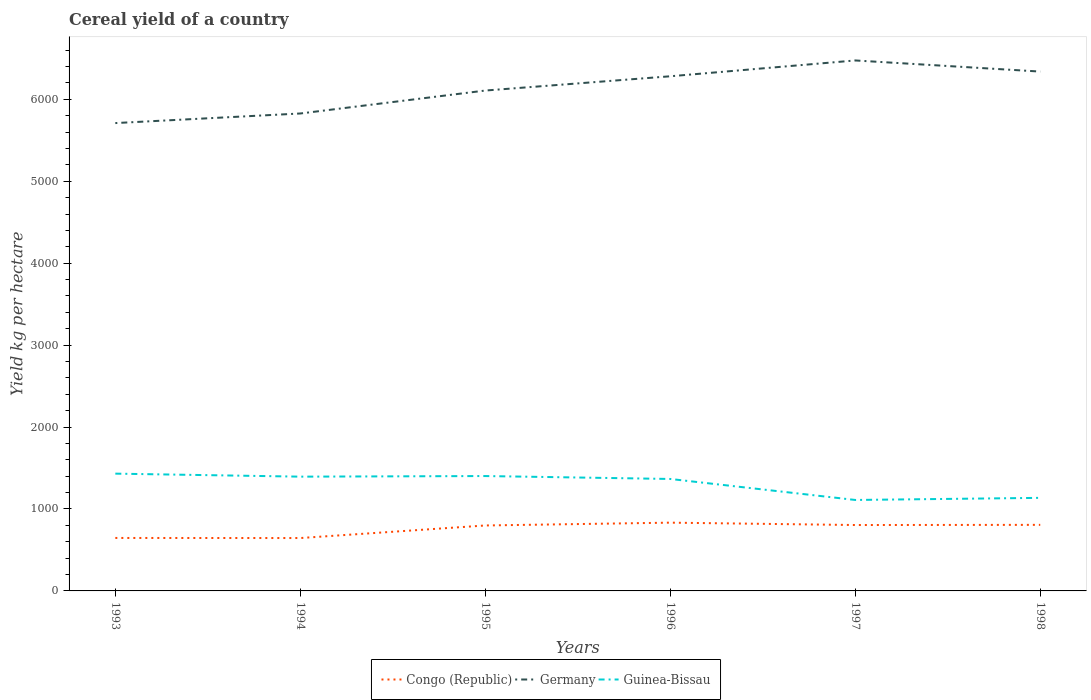Is the number of lines equal to the number of legend labels?
Ensure brevity in your answer.  Yes. Across all years, what is the maximum total cereal yield in Germany?
Offer a very short reply. 5710.53. What is the total total cereal yield in Germany in the graph?
Your answer should be very brief. -117.07. What is the difference between the highest and the second highest total cereal yield in Congo (Republic)?
Provide a short and direct response. 187.81. What is the difference between the highest and the lowest total cereal yield in Guinea-Bissau?
Provide a succinct answer. 4. How many lines are there?
Your response must be concise. 3. How many years are there in the graph?
Give a very brief answer. 6. Are the values on the major ticks of Y-axis written in scientific E-notation?
Give a very brief answer. No. Does the graph contain any zero values?
Ensure brevity in your answer.  No. Does the graph contain grids?
Provide a short and direct response. No. How many legend labels are there?
Ensure brevity in your answer.  3. How are the legend labels stacked?
Offer a very short reply. Horizontal. What is the title of the graph?
Ensure brevity in your answer.  Cereal yield of a country. What is the label or title of the X-axis?
Your answer should be compact. Years. What is the label or title of the Y-axis?
Your answer should be compact. Yield kg per hectare. What is the Yield kg per hectare in Congo (Republic) in 1993?
Your answer should be compact. 646.49. What is the Yield kg per hectare in Germany in 1993?
Your response must be concise. 5710.53. What is the Yield kg per hectare of Guinea-Bissau in 1993?
Your answer should be very brief. 1431.55. What is the Yield kg per hectare of Congo (Republic) in 1994?
Make the answer very short. 645.48. What is the Yield kg per hectare of Germany in 1994?
Your answer should be very brief. 5827.6. What is the Yield kg per hectare of Guinea-Bissau in 1994?
Provide a succinct answer. 1394.79. What is the Yield kg per hectare of Congo (Republic) in 1995?
Keep it short and to the point. 798.93. What is the Yield kg per hectare of Germany in 1995?
Your response must be concise. 6107.68. What is the Yield kg per hectare of Guinea-Bissau in 1995?
Ensure brevity in your answer.  1402.23. What is the Yield kg per hectare of Congo (Republic) in 1996?
Keep it short and to the point. 833.29. What is the Yield kg per hectare in Germany in 1996?
Make the answer very short. 6281.85. What is the Yield kg per hectare in Guinea-Bissau in 1996?
Provide a succinct answer. 1366.54. What is the Yield kg per hectare of Congo (Republic) in 1997?
Offer a very short reply. 804.34. What is the Yield kg per hectare of Germany in 1997?
Provide a succinct answer. 6474.95. What is the Yield kg per hectare in Guinea-Bissau in 1997?
Offer a terse response. 1110.25. What is the Yield kg per hectare of Congo (Republic) in 1998?
Your answer should be very brief. 806.46. What is the Yield kg per hectare in Germany in 1998?
Give a very brief answer. 6339.19. What is the Yield kg per hectare in Guinea-Bissau in 1998?
Your answer should be compact. 1136. Across all years, what is the maximum Yield kg per hectare of Congo (Republic)?
Make the answer very short. 833.29. Across all years, what is the maximum Yield kg per hectare of Germany?
Ensure brevity in your answer.  6474.95. Across all years, what is the maximum Yield kg per hectare of Guinea-Bissau?
Offer a very short reply. 1431.55. Across all years, what is the minimum Yield kg per hectare in Congo (Republic)?
Offer a terse response. 645.48. Across all years, what is the minimum Yield kg per hectare of Germany?
Your answer should be compact. 5710.53. Across all years, what is the minimum Yield kg per hectare in Guinea-Bissau?
Your response must be concise. 1110.25. What is the total Yield kg per hectare in Congo (Republic) in the graph?
Provide a succinct answer. 4534.99. What is the total Yield kg per hectare in Germany in the graph?
Your answer should be compact. 3.67e+04. What is the total Yield kg per hectare of Guinea-Bissau in the graph?
Your answer should be compact. 7841.37. What is the difference between the Yield kg per hectare in Congo (Republic) in 1993 and that in 1994?
Give a very brief answer. 1.01. What is the difference between the Yield kg per hectare of Germany in 1993 and that in 1994?
Your answer should be compact. -117.07. What is the difference between the Yield kg per hectare in Guinea-Bissau in 1993 and that in 1994?
Offer a terse response. 36.76. What is the difference between the Yield kg per hectare of Congo (Republic) in 1993 and that in 1995?
Offer a very short reply. -152.44. What is the difference between the Yield kg per hectare of Germany in 1993 and that in 1995?
Your answer should be compact. -397.15. What is the difference between the Yield kg per hectare in Guinea-Bissau in 1993 and that in 1995?
Offer a very short reply. 29.33. What is the difference between the Yield kg per hectare of Congo (Republic) in 1993 and that in 1996?
Offer a terse response. -186.8. What is the difference between the Yield kg per hectare in Germany in 1993 and that in 1996?
Provide a short and direct response. -571.32. What is the difference between the Yield kg per hectare of Guinea-Bissau in 1993 and that in 1996?
Give a very brief answer. 65.01. What is the difference between the Yield kg per hectare of Congo (Republic) in 1993 and that in 1997?
Make the answer very short. -157.84. What is the difference between the Yield kg per hectare in Germany in 1993 and that in 1997?
Make the answer very short. -764.43. What is the difference between the Yield kg per hectare of Guinea-Bissau in 1993 and that in 1997?
Your answer should be compact. 321.3. What is the difference between the Yield kg per hectare of Congo (Republic) in 1993 and that in 1998?
Give a very brief answer. -159.96. What is the difference between the Yield kg per hectare in Germany in 1993 and that in 1998?
Offer a terse response. -628.66. What is the difference between the Yield kg per hectare in Guinea-Bissau in 1993 and that in 1998?
Give a very brief answer. 295.55. What is the difference between the Yield kg per hectare of Congo (Republic) in 1994 and that in 1995?
Keep it short and to the point. -153.46. What is the difference between the Yield kg per hectare of Germany in 1994 and that in 1995?
Provide a short and direct response. -280.08. What is the difference between the Yield kg per hectare in Guinea-Bissau in 1994 and that in 1995?
Your response must be concise. -7.43. What is the difference between the Yield kg per hectare in Congo (Republic) in 1994 and that in 1996?
Keep it short and to the point. -187.81. What is the difference between the Yield kg per hectare of Germany in 1994 and that in 1996?
Give a very brief answer. -454.25. What is the difference between the Yield kg per hectare in Guinea-Bissau in 1994 and that in 1996?
Offer a very short reply. 28.25. What is the difference between the Yield kg per hectare of Congo (Republic) in 1994 and that in 1997?
Ensure brevity in your answer.  -158.86. What is the difference between the Yield kg per hectare in Germany in 1994 and that in 1997?
Provide a succinct answer. -647.36. What is the difference between the Yield kg per hectare in Guinea-Bissau in 1994 and that in 1997?
Ensure brevity in your answer.  284.54. What is the difference between the Yield kg per hectare of Congo (Republic) in 1994 and that in 1998?
Your answer should be compact. -160.98. What is the difference between the Yield kg per hectare of Germany in 1994 and that in 1998?
Give a very brief answer. -511.59. What is the difference between the Yield kg per hectare of Guinea-Bissau in 1994 and that in 1998?
Ensure brevity in your answer.  258.79. What is the difference between the Yield kg per hectare of Congo (Republic) in 1995 and that in 1996?
Ensure brevity in your answer.  -34.35. What is the difference between the Yield kg per hectare in Germany in 1995 and that in 1996?
Your answer should be very brief. -174.17. What is the difference between the Yield kg per hectare in Guinea-Bissau in 1995 and that in 1996?
Keep it short and to the point. 35.68. What is the difference between the Yield kg per hectare of Congo (Republic) in 1995 and that in 1997?
Give a very brief answer. -5.4. What is the difference between the Yield kg per hectare of Germany in 1995 and that in 1997?
Your answer should be compact. -367.28. What is the difference between the Yield kg per hectare of Guinea-Bissau in 1995 and that in 1997?
Your answer should be compact. 291.98. What is the difference between the Yield kg per hectare of Congo (Republic) in 1995 and that in 1998?
Give a very brief answer. -7.52. What is the difference between the Yield kg per hectare of Germany in 1995 and that in 1998?
Make the answer very short. -231.51. What is the difference between the Yield kg per hectare of Guinea-Bissau in 1995 and that in 1998?
Offer a very short reply. 266.23. What is the difference between the Yield kg per hectare in Congo (Republic) in 1996 and that in 1997?
Provide a succinct answer. 28.95. What is the difference between the Yield kg per hectare in Germany in 1996 and that in 1997?
Provide a succinct answer. -193.11. What is the difference between the Yield kg per hectare of Guinea-Bissau in 1996 and that in 1997?
Provide a short and direct response. 256.29. What is the difference between the Yield kg per hectare in Congo (Republic) in 1996 and that in 1998?
Keep it short and to the point. 26.83. What is the difference between the Yield kg per hectare of Germany in 1996 and that in 1998?
Offer a terse response. -57.34. What is the difference between the Yield kg per hectare of Guinea-Bissau in 1996 and that in 1998?
Ensure brevity in your answer.  230.54. What is the difference between the Yield kg per hectare of Congo (Republic) in 1997 and that in 1998?
Offer a very short reply. -2.12. What is the difference between the Yield kg per hectare of Germany in 1997 and that in 1998?
Keep it short and to the point. 135.76. What is the difference between the Yield kg per hectare in Guinea-Bissau in 1997 and that in 1998?
Offer a terse response. -25.75. What is the difference between the Yield kg per hectare in Congo (Republic) in 1993 and the Yield kg per hectare in Germany in 1994?
Keep it short and to the point. -5181.1. What is the difference between the Yield kg per hectare in Congo (Republic) in 1993 and the Yield kg per hectare in Guinea-Bissau in 1994?
Make the answer very short. -748.3. What is the difference between the Yield kg per hectare of Germany in 1993 and the Yield kg per hectare of Guinea-Bissau in 1994?
Offer a very short reply. 4315.73. What is the difference between the Yield kg per hectare in Congo (Republic) in 1993 and the Yield kg per hectare in Germany in 1995?
Offer a terse response. -5461.18. What is the difference between the Yield kg per hectare in Congo (Republic) in 1993 and the Yield kg per hectare in Guinea-Bissau in 1995?
Keep it short and to the point. -755.73. What is the difference between the Yield kg per hectare in Germany in 1993 and the Yield kg per hectare in Guinea-Bissau in 1995?
Your response must be concise. 4308.3. What is the difference between the Yield kg per hectare of Congo (Republic) in 1993 and the Yield kg per hectare of Germany in 1996?
Keep it short and to the point. -5635.35. What is the difference between the Yield kg per hectare of Congo (Republic) in 1993 and the Yield kg per hectare of Guinea-Bissau in 1996?
Make the answer very short. -720.05. What is the difference between the Yield kg per hectare of Germany in 1993 and the Yield kg per hectare of Guinea-Bissau in 1996?
Offer a very short reply. 4343.99. What is the difference between the Yield kg per hectare of Congo (Republic) in 1993 and the Yield kg per hectare of Germany in 1997?
Offer a very short reply. -5828.46. What is the difference between the Yield kg per hectare of Congo (Republic) in 1993 and the Yield kg per hectare of Guinea-Bissau in 1997?
Your answer should be compact. -463.76. What is the difference between the Yield kg per hectare of Germany in 1993 and the Yield kg per hectare of Guinea-Bissau in 1997?
Make the answer very short. 4600.28. What is the difference between the Yield kg per hectare in Congo (Republic) in 1993 and the Yield kg per hectare in Germany in 1998?
Keep it short and to the point. -5692.7. What is the difference between the Yield kg per hectare of Congo (Republic) in 1993 and the Yield kg per hectare of Guinea-Bissau in 1998?
Give a very brief answer. -489.51. What is the difference between the Yield kg per hectare of Germany in 1993 and the Yield kg per hectare of Guinea-Bissau in 1998?
Provide a succinct answer. 4574.53. What is the difference between the Yield kg per hectare in Congo (Republic) in 1994 and the Yield kg per hectare in Germany in 1995?
Offer a very short reply. -5462.2. What is the difference between the Yield kg per hectare of Congo (Republic) in 1994 and the Yield kg per hectare of Guinea-Bissau in 1995?
Ensure brevity in your answer.  -756.75. What is the difference between the Yield kg per hectare of Germany in 1994 and the Yield kg per hectare of Guinea-Bissau in 1995?
Keep it short and to the point. 4425.37. What is the difference between the Yield kg per hectare of Congo (Republic) in 1994 and the Yield kg per hectare of Germany in 1996?
Give a very brief answer. -5636.37. What is the difference between the Yield kg per hectare in Congo (Republic) in 1994 and the Yield kg per hectare in Guinea-Bissau in 1996?
Make the answer very short. -721.06. What is the difference between the Yield kg per hectare in Germany in 1994 and the Yield kg per hectare in Guinea-Bissau in 1996?
Offer a terse response. 4461.05. What is the difference between the Yield kg per hectare in Congo (Republic) in 1994 and the Yield kg per hectare in Germany in 1997?
Offer a very short reply. -5829.48. What is the difference between the Yield kg per hectare of Congo (Republic) in 1994 and the Yield kg per hectare of Guinea-Bissau in 1997?
Provide a short and direct response. -464.77. What is the difference between the Yield kg per hectare in Germany in 1994 and the Yield kg per hectare in Guinea-Bissau in 1997?
Provide a succinct answer. 4717.35. What is the difference between the Yield kg per hectare of Congo (Republic) in 1994 and the Yield kg per hectare of Germany in 1998?
Offer a terse response. -5693.71. What is the difference between the Yield kg per hectare of Congo (Republic) in 1994 and the Yield kg per hectare of Guinea-Bissau in 1998?
Ensure brevity in your answer.  -490.52. What is the difference between the Yield kg per hectare in Germany in 1994 and the Yield kg per hectare in Guinea-Bissau in 1998?
Your answer should be very brief. 4691.6. What is the difference between the Yield kg per hectare of Congo (Republic) in 1995 and the Yield kg per hectare of Germany in 1996?
Offer a terse response. -5482.91. What is the difference between the Yield kg per hectare of Congo (Republic) in 1995 and the Yield kg per hectare of Guinea-Bissau in 1996?
Give a very brief answer. -567.61. What is the difference between the Yield kg per hectare of Germany in 1995 and the Yield kg per hectare of Guinea-Bissau in 1996?
Provide a succinct answer. 4741.13. What is the difference between the Yield kg per hectare of Congo (Republic) in 1995 and the Yield kg per hectare of Germany in 1997?
Your answer should be very brief. -5676.02. What is the difference between the Yield kg per hectare of Congo (Republic) in 1995 and the Yield kg per hectare of Guinea-Bissau in 1997?
Your answer should be compact. -311.32. What is the difference between the Yield kg per hectare in Germany in 1995 and the Yield kg per hectare in Guinea-Bissau in 1997?
Make the answer very short. 4997.42. What is the difference between the Yield kg per hectare in Congo (Republic) in 1995 and the Yield kg per hectare in Germany in 1998?
Provide a succinct answer. -5540.25. What is the difference between the Yield kg per hectare of Congo (Republic) in 1995 and the Yield kg per hectare of Guinea-Bissau in 1998?
Ensure brevity in your answer.  -337.07. What is the difference between the Yield kg per hectare of Germany in 1995 and the Yield kg per hectare of Guinea-Bissau in 1998?
Ensure brevity in your answer.  4971.67. What is the difference between the Yield kg per hectare of Congo (Republic) in 1996 and the Yield kg per hectare of Germany in 1997?
Provide a succinct answer. -5641.66. What is the difference between the Yield kg per hectare in Congo (Republic) in 1996 and the Yield kg per hectare in Guinea-Bissau in 1997?
Offer a very short reply. -276.96. What is the difference between the Yield kg per hectare in Germany in 1996 and the Yield kg per hectare in Guinea-Bissau in 1997?
Offer a terse response. 5171.6. What is the difference between the Yield kg per hectare in Congo (Republic) in 1996 and the Yield kg per hectare in Germany in 1998?
Your answer should be very brief. -5505.9. What is the difference between the Yield kg per hectare in Congo (Republic) in 1996 and the Yield kg per hectare in Guinea-Bissau in 1998?
Make the answer very short. -302.71. What is the difference between the Yield kg per hectare in Germany in 1996 and the Yield kg per hectare in Guinea-Bissau in 1998?
Make the answer very short. 5145.85. What is the difference between the Yield kg per hectare of Congo (Republic) in 1997 and the Yield kg per hectare of Germany in 1998?
Offer a very short reply. -5534.85. What is the difference between the Yield kg per hectare in Congo (Republic) in 1997 and the Yield kg per hectare in Guinea-Bissau in 1998?
Provide a succinct answer. -331.66. What is the difference between the Yield kg per hectare of Germany in 1997 and the Yield kg per hectare of Guinea-Bissau in 1998?
Your response must be concise. 5338.95. What is the average Yield kg per hectare of Congo (Republic) per year?
Give a very brief answer. 755.83. What is the average Yield kg per hectare in Germany per year?
Your answer should be compact. 6123.63. What is the average Yield kg per hectare in Guinea-Bissau per year?
Ensure brevity in your answer.  1306.89. In the year 1993, what is the difference between the Yield kg per hectare in Congo (Republic) and Yield kg per hectare in Germany?
Make the answer very short. -5064.03. In the year 1993, what is the difference between the Yield kg per hectare in Congo (Republic) and Yield kg per hectare in Guinea-Bissau?
Provide a short and direct response. -785.06. In the year 1993, what is the difference between the Yield kg per hectare of Germany and Yield kg per hectare of Guinea-Bissau?
Provide a succinct answer. 4278.97. In the year 1994, what is the difference between the Yield kg per hectare of Congo (Republic) and Yield kg per hectare of Germany?
Give a very brief answer. -5182.12. In the year 1994, what is the difference between the Yield kg per hectare of Congo (Republic) and Yield kg per hectare of Guinea-Bissau?
Ensure brevity in your answer.  -749.31. In the year 1994, what is the difference between the Yield kg per hectare in Germany and Yield kg per hectare in Guinea-Bissau?
Provide a short and direct response. 4432.8. In the year 1995, what is the difference between the Yield kg per hectare in Congo (Republic) and Yield kg per hectare in Germany?
Give a very brief answer. -5308.74. In the year 1995, what is the difference between the Yield kg per hectare in Congo (Republic) and Yield kg per hectare in Guinea-Bissau?
Offer a terse response. -603.29. In the year 1995, what is the difference between the Yield kg per hectare of Germany and Yield kg per hectare of Guinea-Bissau?
Your answer should be compact. 4705.45. In the year 1996, what is the difference between the Yield kg per hectare in Congo (Republic) and Yield kg per hectare in Germany?
Provide a short and direct response. -5448.56. In the year 1996, what is the difference between the Yield kg per hectare of Congo (Republic) and Yield kg per hectare of Guinea-Bissau?
Your answer should be compact. -533.25. In the year 1996, what is the difference between the Yield kg per hectare in Germany and Yield kg per hectare in Guinea-Bissau?
Your answer should be very brief. 4915.31. In the year 1997, what is the difference between the Yield kg per hectare in Congo (Republic) and Yield kg per hectare in Germany?
Provide a short and direct response. -5670.62. In the year 1997, what is the difference between the Yield kg per hectare of Congo (Republic) and Yield kg per hectare of Guinea-Bissau?
Provide a succinct answer. -305.91. In the year 1997, what is the difference between the Yield kg per hectare in Germany and Yield kg per hectare in Guinea-Bissau?
Offer a very short reply. 5364.7. In the year 1998, what is the difference between the Yield kg per hectare in Congo (Republic) and Yield kg per hectare in Germany?
Give a very brief answer. -5532.73. In the year 1998, what is the difference between the Yield kg per hectare of Congo (Republic) and Yield kg per hectare of Guinea-Bissau?
Provide a succinct answer. -329.54. In the year 1998, what is the difference between the Yield kg per hectare of Germany and Yield kg per hectare of Guinea-Bissau?
Provide a succinct answer. 5203.19. What is the ratio of the Yield kg per hectare in Congo (Republic) in 1993 to that in 1994?
Provide a succinct answer. 1. What is the ratio of the Yield kg per hectare of Germany in 1993 to that in 1994?
Your response must be concise. 0.98. What is the ratio of the Yield kg per hectare in Guinea-Bissau in 1993 to that in 1994?
Your answer should be compact. 1.03. What is the ratio of the Yield kg per hectare of Congo (Republic) in 1993 to that in 1995?
Make the answer very short. 0.81. What is the ratio of the Yield kg per hectare of Germany in 1993 to that in 1995?
Ensure brevity in your answer.  0.94. What is the ratio of the Yield kg per hectare in Guinea-Bissau in 1993 to that in 1995?
Provide a succinct answer. 1.02. What is the ratio of the Yield kg per hectare in Congo (Republic) in 1993 to that in 1996?
Provide a succinct answer. 0.78. What is the ratio of the Yield kg per hectare in Guinea-Bissau in 1993 to that in 1996?
Offer a terse response. 1.05. What is the ratio of the Yield kg per hectare of Congo (Republic) in 1993 to that in 1997?
Offer a terse response. 0.8. What is the ratio of the Yield kg per hectare of Germany in 1993 to that in 1997?
Your answer should be very brief. 0.88. What is the ratio of the Yield kg per hectare of Guinea-Bissau in 1993 to that in 1997?
Ensure brevity in your answer.  1.29. What is the ratio of the Yield kg per hectare of Congo (Republic) in 1993 to that in 1998?
Keep it short and to the point. 0.8. What is the ratio of the Yield kg per hectare of Germany in 1993 to that in 1998?
Offer a terse response. 0.9. What is the ratio of the Yield kg per hectare in Guinea-Bissau in 1993 to that in 1998?
Provide a succinct answer. 1.26. What is the ratio of the Yield kg per hectare in Congo (Republic) in 1994 to that in 1995?
Provide a succinct answer. 0.81. What is the ratio of the Yield kg per hectare in Germany in 1994 to that in 1995?
Your answer should be very brief. 0.95. What is the ratio of the Yield kg per hectare in Congo (Republic) in 1994 to that in 1996?
Your response must be concise. 0.77. What is the ratio of the Yield kg per hectare of Germany in 1994 to that in 1996?
Make the answer very short. 0.93. What is the ratio of the Yield kg per hectare in Guinea-Bissau in 1994 to that in 1996?
Your answer should be compact. 1.02. What is the ratio of the Yield kg per hectare of Congo (Republic) in 1994 to that in 1997?
Your answer should be very brief. 0.8. What is the ratio of the Yield kg per hectare of Guinea-Bissau in 1994 to that in 1997?
Provide a short and direct response. 1.26. What is the ratio of the Yield kg per hectare in Congo (Republic) in 1994 to that in 1998?
Your answer should be compact. 0.8. What is the ratio of the Yield kg per hectare of Germany in 1994 to that in 1998?
Your answer should be compact. 0.92. What is the ratio of the Yield kg per hectare of Guinea-Bissau in 1994 to that in 1998?
Your response must be concise. 1.23. What is the ratio of the Yield kg per hectare in Congo (Republic) in 1995 to that in 1996?
Keep it short and to the point. 0.96. What is the ratio of the Yield kg per hectare in Germany in 1995 to that in 1996?
Provide a succinct answer. 0.97. What is the ratio of the Yield kg per hectare of Guinea-Bissau in 1995 to that in 1996?
Keep it short and to the point. 1.03. What is the ratio of the Yield kg per hectare in Congo (Republic) in 1995 to that in 1997?
Give a very brief answer. 0.99. What is the ratio of the Yield kg per hectare in Germany in 1995 to that in 1997?
Make the answer very short. 0.94. What is the ratio of the Yield kg per hectare in Guinea-Bissau in 1995 to that in 1997?
Your answer should be compact. 1.26. What is the ratio of the Yield kg per hectare of Congo (Republic) in 1995 to that in 1998?
Ensure brevity in your answer.  0.99. What is the ratio of the Yield kg per hectare of Germany in 1995 to that in 1998?
Provide a short and direct response. 0.96. What is the ratio of the Yield kg per hectare in Guinea-Bissau in 1995 to that in 1998?
Provide a short and direct response. 1.23. What is the ratio of the Yield kg per hectare in Congo (Republic) in 1996 to that in 1997?
Offer a very short reply. 1.04. What is the ratio of the Yield kg per hectare of Germany in 1996 to that in 1997?
Offer a terse response. 0.97. What is the ratio of the Yield kg per hectare of Guinea-Bissau in 1996 to that in 1997?
Give a very brief answer. 1.23. What is the ratio of the Yield kg per hectare in Guinea-Bissau in 1996 to that in 1998?
Ensure brevity in your answer.  1.2. What is the ratio of the Yield kg per hectare in Germany in 1997 to that in 1998?
Your answer should be very brief. 1.02. What is the ratio of the Yield kg per hectare in Guinea-Bissau in 1997 to that in 1998?
Make the answer very short. 0.98. What is the difference between the highest and the second highest Yield kg per hectare in Congo (Republic)?
Give a very brief answer. 26.83. What is the difference between the highest and the second highest Yield kg per hectare in Germany?
Provide a succinct answer. 135.76. What is the difference between the highest and the second highest Yield kg per hectare of Guinea-Bissau?
Provide a succinct answer. 29.33. What is the difference between the highest and the lowest Yield kg per hectare of Congo (Republic)?
Your answer should be very brief. 187.81. What is the difference between the highest and the lowest Yield kg per hectare of Germany?
Provide a succinct answer. 764.43. What is the difference between the highest and the lowest Yield kg per hectare in Guinea-Bissau?
Offer a very short reply. 321.3. 